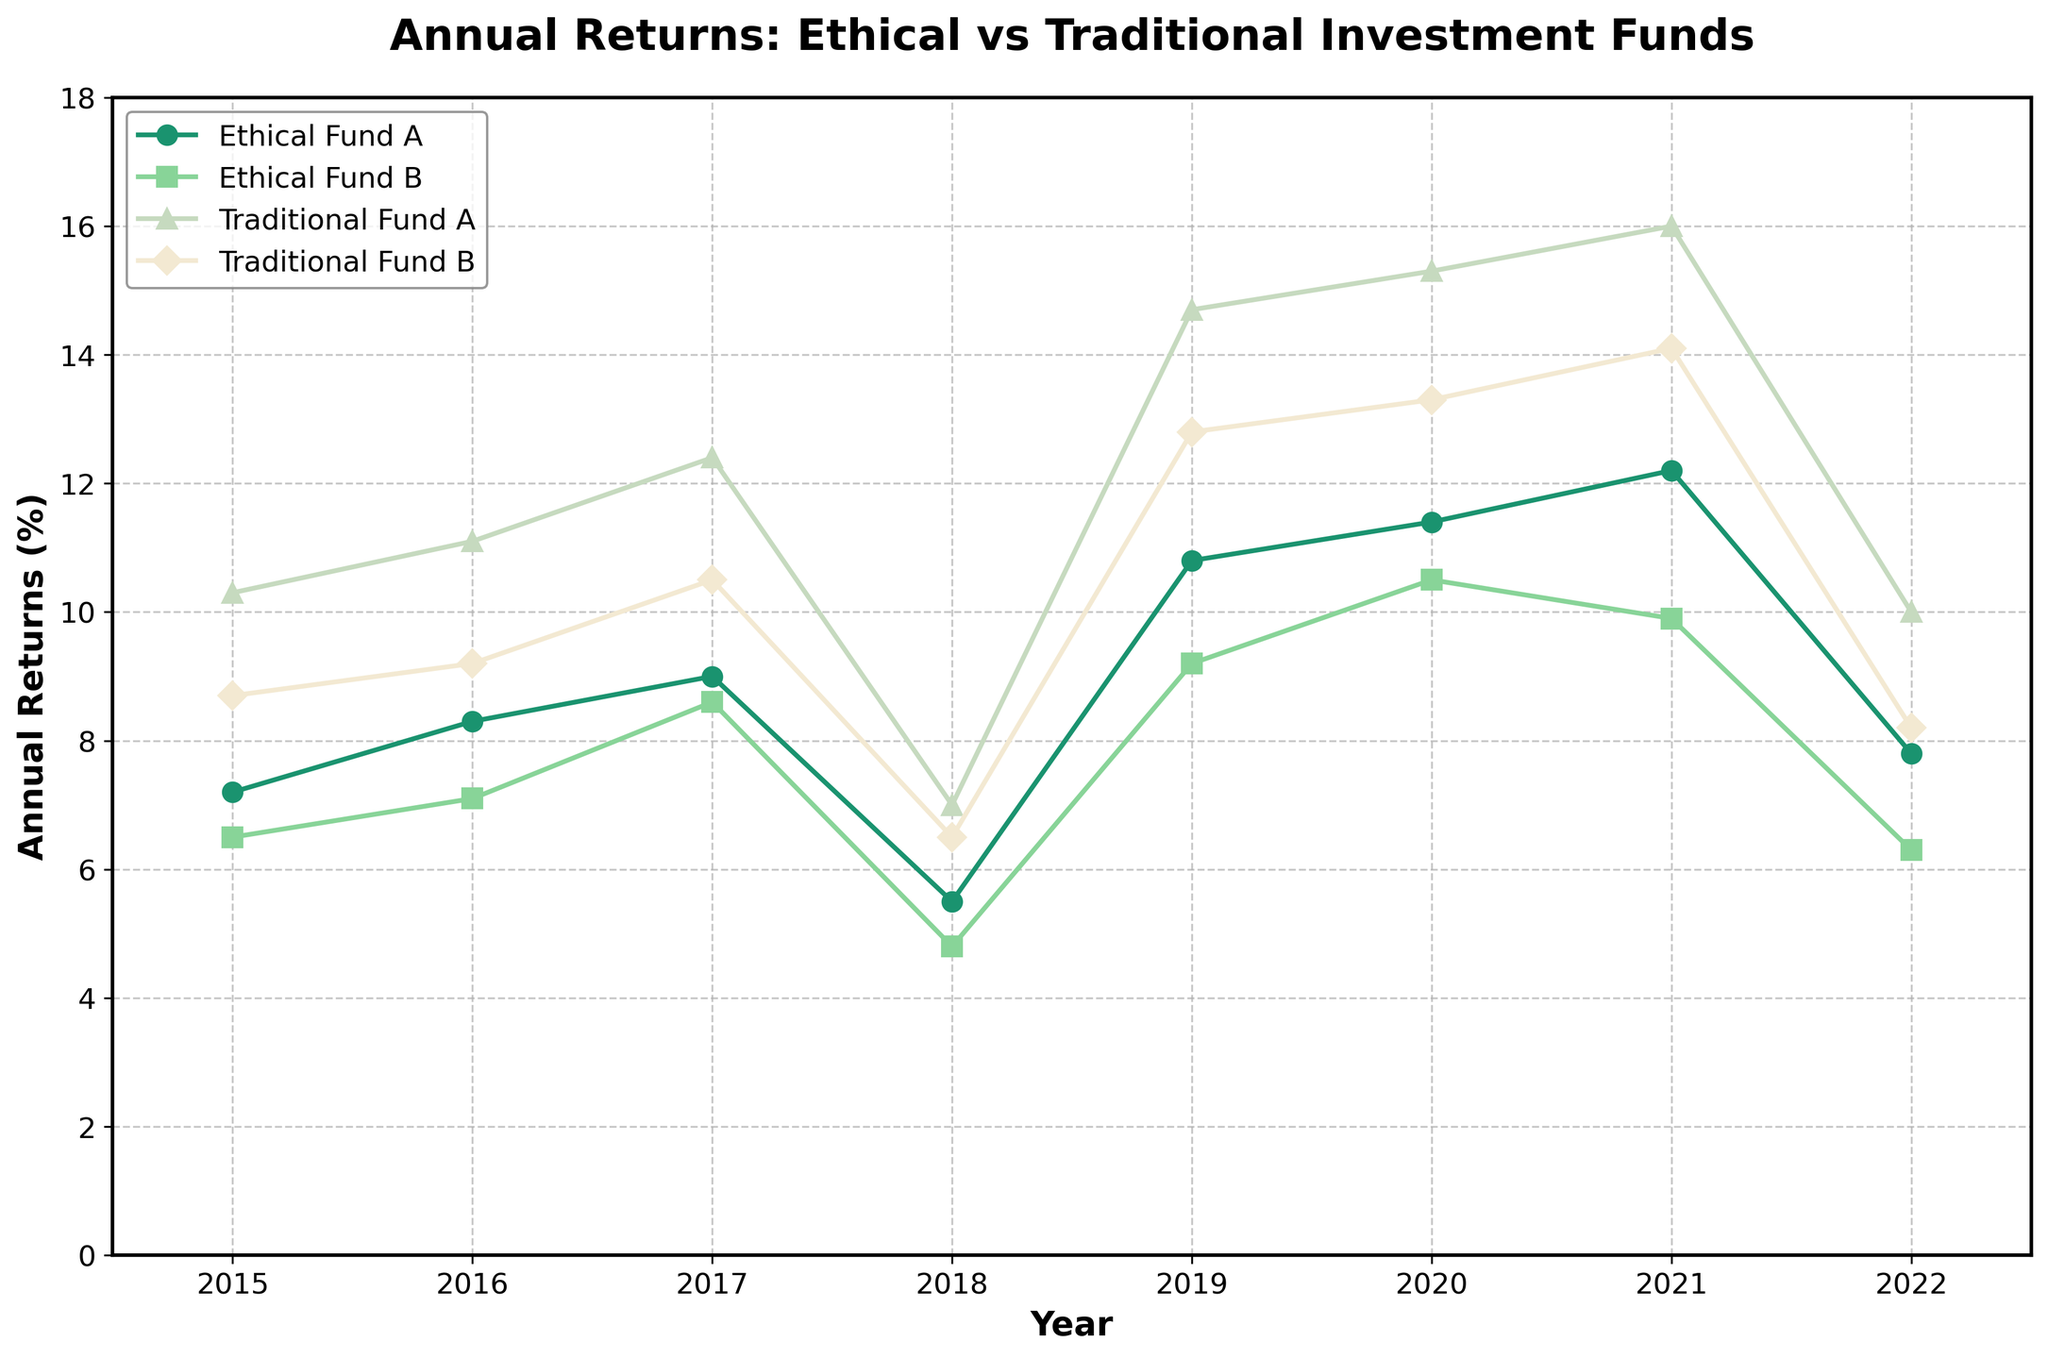What is the title of the figure? The title of the figure is located at the top and mentions both Ethical and Traditional Investment Funds.
Answer: Annual Returns: Ethical vs Traditional Investment Funds How many years are plotted on the x-axis? To find the number of years, count the tick marks along the x-axis.
Answer: 8 Which fund had the highest return in 2019? Compare the values of all funds in the year 2019, indicated on the x-axis, to identify the highest one.
Answer: Traditional Fund A How did the returns of Ethical Fund B change from 2017 to 2018? Look at the plotted points for Ethical Fund B in 2017 and 2018 and observe the change.
Answer: Decreased Which fund showed the most considerable annual return in 2020? Find the highest plotted point for the year 2020 on the x-axis and identify the corresponding fund.
Answer: Traditional Fund A What's the average annual return for Ethical Fund A over the plotted years? Sum the returns of Ethical Fund A for all years and divide by the number of years. (7.2 + 8.3 + 9.0 + 5.5 + 10.8 + 11.4 + 12.2 + 7.8) / 8 = 9.15
Answer: 9.15% How do the returns of Ethical Fund A in 2015 compare to Traditional Fund B in the same year? Observe the plotted points for both funds in 2015 and compare their values.
Answer: Ethical Fund A is lower Which fund had the smallest return in 2022? Identify the lowest plotted point for the year 2022 on the x-axis and determine the corresponding fund.
Answer: Ethical Fund B What is the trend of Traditional Fund A from 2015 to 2021? Observe the plotted points for Traditional Fund A over these years and describe the overall direction.
Answer: Increasing trend Is there any year where Ethical Fund A outperformed all other funds? Compare the returns of Ethical Fund A with the other funds year by year to see if there is any year where it had the highest return.
Answer: No 